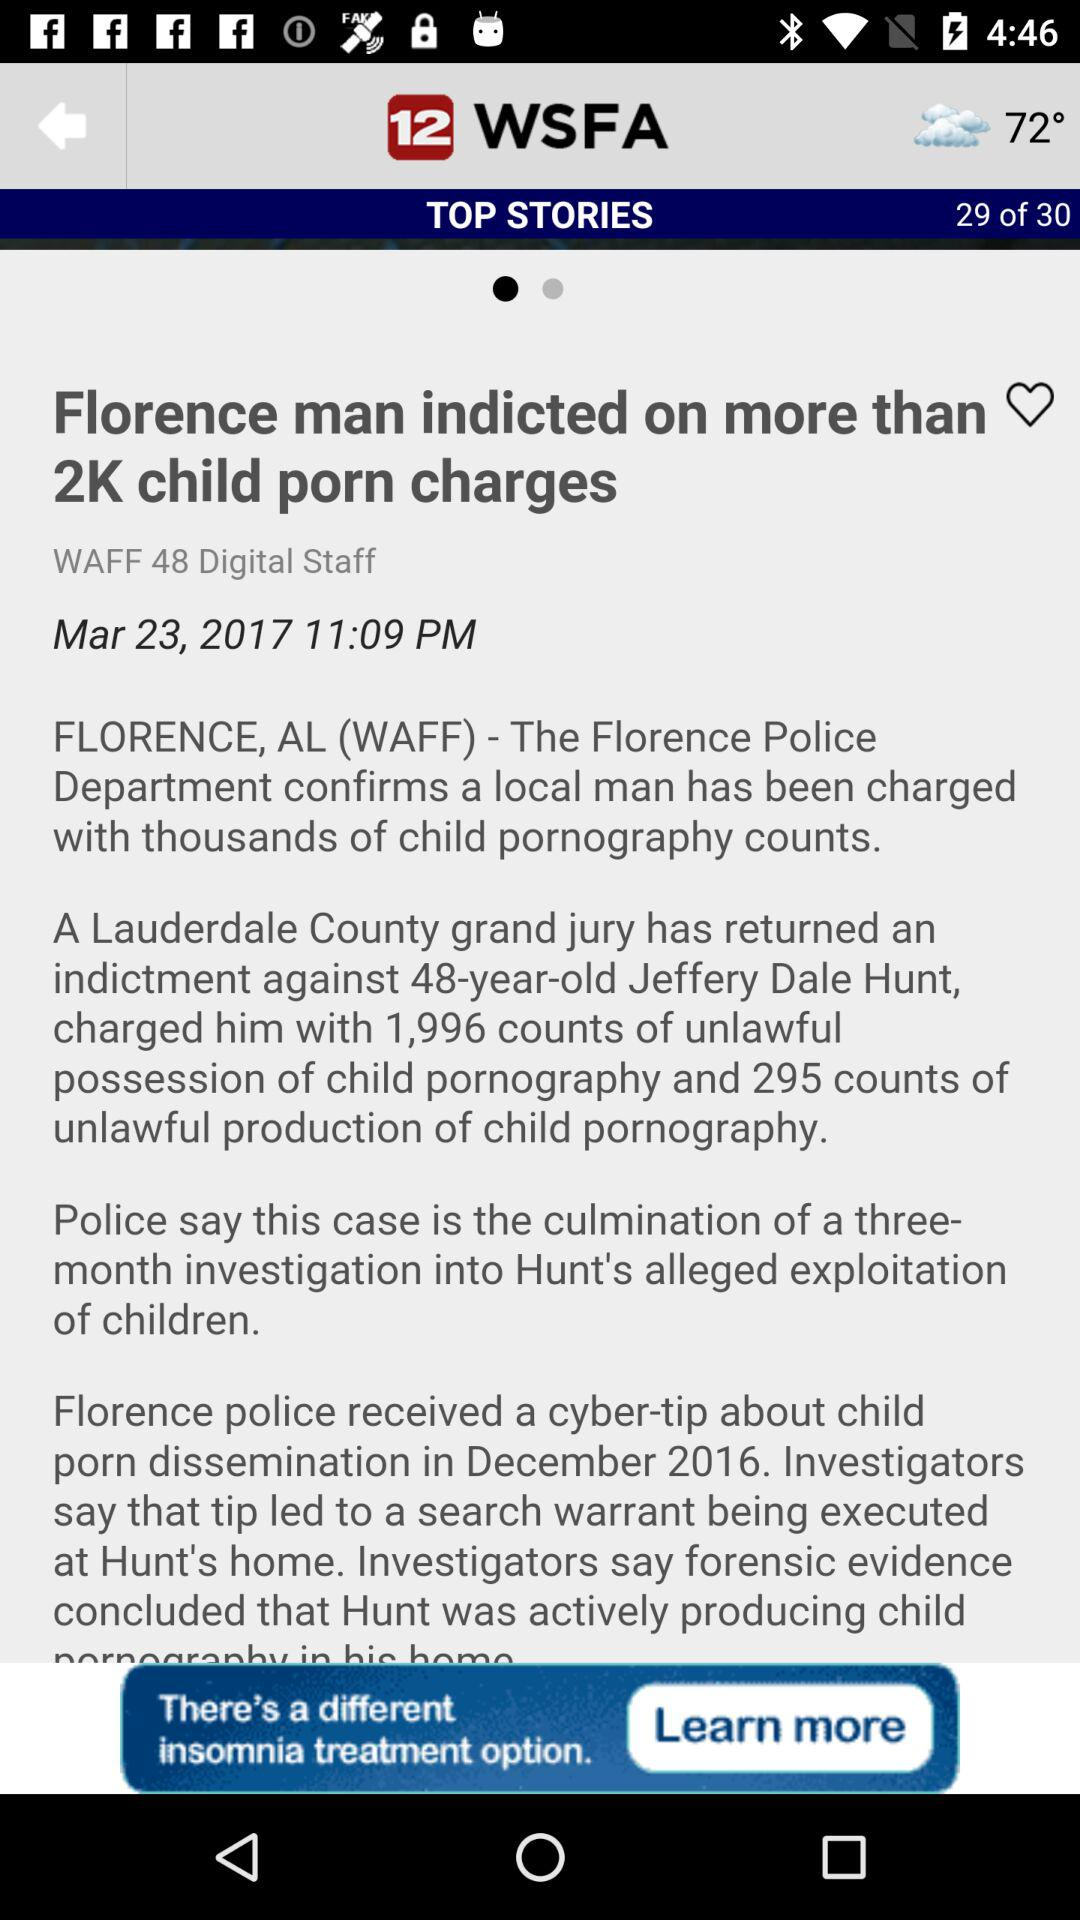How many total pages are there for Top Stories? The total number of pages is 30. 